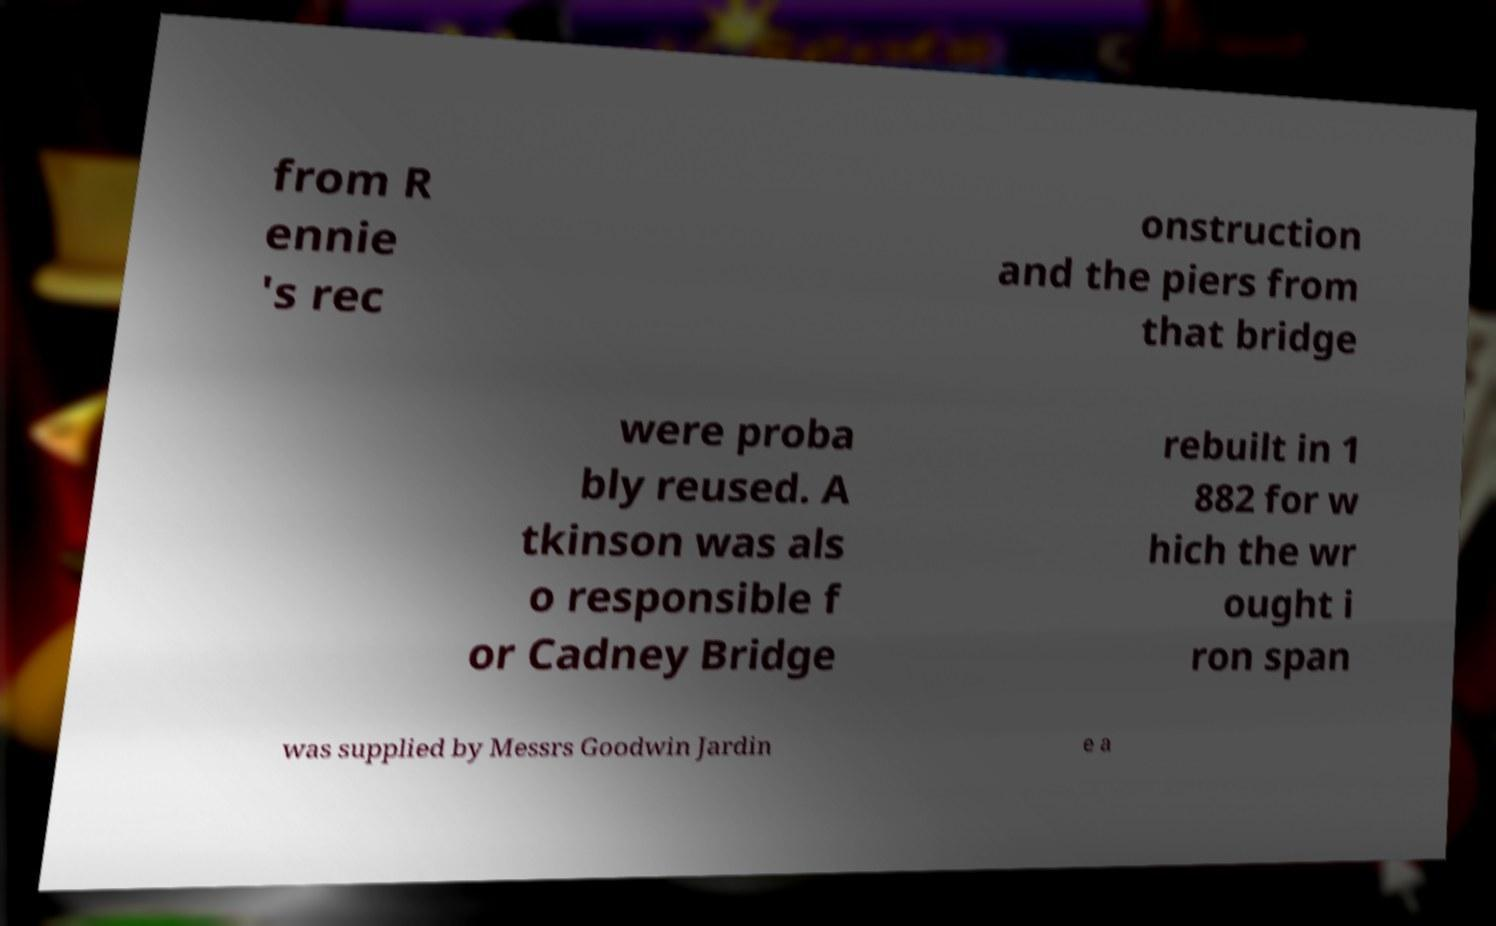Could you assist in decoding the text presented in this image and type it out clearly? from R ennie 's rec onstruction and the piers from that bridge were proba bly reused. A tkinson was als o responsible f or Cadney Bridge rebuilt in 1 882 for w hich the wr ought i ron span was supplied by Messrs Goodwin Jardin e a 